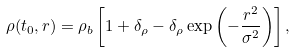<formula> <loc_0><loc_0><loc_500><loc_500>\rho ( t _ { 0 } , r ) = \rho _ { b } \left [ 1 + \delta _ { \rho } - \delta _ { \rho } \exp \left ( - \frac { r ^ { 2 } } { \sigma ^ { 2 } } \right ) \right ] ,</formula> 